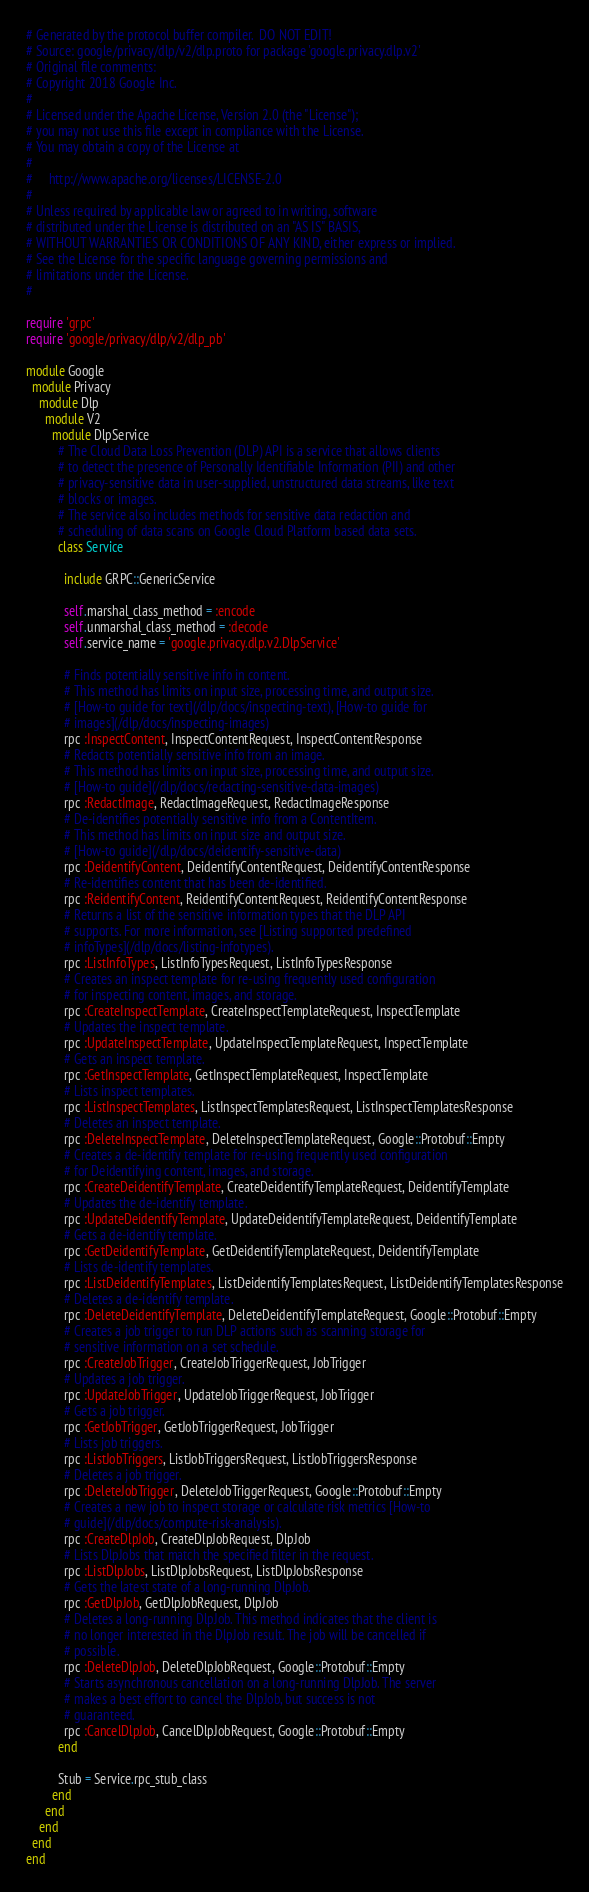<code> <loc_0><loc_0><loc_500><loc_500><_Ruby_># Generated by the protocol buffer compiler.  DO NOT EDIT!
# Source: google/privacy/dlp/v2/dlp.proto for package 'google.privacy.dlp.v2'
# Original file comments:
# Copyright 2018 Google Inc.
#
# Licensed under the Apache License, Version 2.0 (the "License");
# you may not use this file except in compliance with the License.
# You may obtain a copy of the License at
#
#     http://www.apache.org/licenses/LICENSE-2.0
#
# Unless required by applicable law or agreed to in writing, software
# distributed under the License is distributed on an "AS IS" BASIS,
# WITHOUT WARRANTIES OR CONDITIONS OF ANY KIND, either express or implied.
# See the License for the specific language governing permissions and
# limitations under the License.
#

require 'grpc'
require 'google/privacy/dlp/v2/dlp_pb'

module Google
  module Privacy
    module Dlp
      module V2
        module DlpService
          # The Cloud Data Loss Prevention (DLP) API is a service that allows clients
          # to detect the presence of Personally Identifiable Information (PII) and other
          # privacy-sensitive data in user-supplied, unstructured data streams, like text
          # blocks or images.
          # The service also includes methods for sensitive data redaction and
          # scheduling of data scans on Google Cloud Platform based data sets.
          class Service

            include GRPC::GenericService

            self.marshal_class_method = :encode
            self.unmarshal_class_method = :decode
            self.service_name = 'google.privacy.dlp.v2.DlpService'

            # Finds potentially sensitive info in content.
            # This method has limits on input size, processing time, and output size.
            # [How-to guide for text](/dlp/docs/inspecting-text), [How-to guide for
            # images](/dlp/docs/inspecting-images)
            rpc :InspectContent, InspectContentRequest, InspectContentResponse
            # Redacts potentially sensitive info from an image.
            # This method has limits on input size, processing time, and output size.
            # [How-to guide](/dlp/docs/redacting-sensitive-data-images)
            rpc :RedactImage, RedactImageRequest, RedactImageResponse
            # De-identifies potentially sensitive info from a ContentItem.
            # This method has limits on input size and output size.
            # [How-to guide](/dlp/docs/deidentify-sensitive-data)
            rpc :DeidentifyContent, DeidentifyContentRequest, DeidentifyContentResponse
            # Re-identifies content that has been de-identified.
            rpc :ReidentifyContent, ReidentifyContentRequest, ReidentifyContentResponse
            # Returns a list of the sensitive information types that the DLP API
            # supports. For more information, see [Listing supported predefined
            # infoTypes](/dlp/docs/listing-infotypes).
            rpc :ListInfoTypes, ListInfoTypesRequest, ListInfoTypesResponse
            # Creates an inspect template for re-using frequently used configuration
            # for inspecting content, images, and storage.
            rpc :CreateInspectTemplate, CreateInspectTemplateRequest, InspectTemplate
            # Updates the inspect template.
            rpc :UpdateInspectTemplate, UpdateInspectTemplateRequest, InspectTemplate
            # Gets an inspect template.
            rpc :GetInspectTemplate, GetInspectTemplateRequest, InspectTemplate
            # Lists inspect templates.
            rpc :ListInspectTemplates, ListInspectTemplatesRequest, ListInspectTemplatesResponse
            # Deletes an inspect template.
            rpc :DeleteInspectTemplate, DeleteInspectTemplateRequest, Google::Protobuf::Empty
            # Creates a de-identify template for re-using frequently used configuration
            # for Deidentifying content, images, and storage.
            rpc :CreateDeidentifyTemplate, CreateDeidentifyTemplateRequest, DeidentifyTemplate
            # Updates the de-identify template.
            rpc :UpdateDeidentifyTemplate, UpdateDeidentifyTemplateRequest, DeidentifyTemplate
            # Gets a de-identify template.
            rpc :GetDeidentifyTemplate, GetDeidentifyTemplateRequest, DeidentifyTemplate
            # Lists de-identify templates.
            rpc :ListDeidentifyTemplates, ListDeidentifyTemplatesRequest, ListDeidentifyTemplatesResponse
            # Deletes a de-identify template.
            rpc :DeleteDeidentifyTemplate, DeleteDeidentifyTemplateRequest, Google::Protobuf::Empty
            # Creates a job trigger to run DLP actions such as scanning storage for
            # sensitive information on a set schedule.
            rpc :CreateJobTrigger, CreateJobTriggerRequest, JobTrigger
            # Updates a job trigger.
            rpc :UpdateJobTrigger, UpdateJobTriggerRequest, JobTrigger
            # Gets a job trigger.
            rpc :GetJobTrigger, GetJobTriggerRequest, JobTrigger
            # Lists job triggers.
            rpc :ListJobTriggers, ListJobTriggersRequest, ListJobTriggersResponse
            # Deletes a job trigger.
            rpc :DeleteJobTrigger, DeleteJobTriggerRequest, Google::Protobuf::Empty
            # Creates a new job to inspect storage or calculate risk metrics [How-to
            # guide](/dlp/docs/compute-risk-analysis).
            rpc :CreateDlpJob, CreateDlpJobRequest, DlpJob
            # Lists DlpJobs that match the specified filter in the request.
            rpc :ListDlpJobs, ListDlpJobsRequest, ListDlpJobsResponse
            # Gets the latest state of a long-running DlpJob.
            rpc :GetDlpJob, GetDlpJobRequest, DlpJob
            # Deletes a long-running DlpJob. This method indicates that the client is
            # no longer interested in the DlpJob result. The job will be cancelled if
            # possible.
            rpc :DeleteDlpJob, DeleteDlpJobRequest, Google::Protobuf::Empty
            # Starts asynchronous cancellation on a long-running DlpJob. The server
            # makes a best effort to cancel the DlpJob, but success is not
            # guaranteed.
            rpc :CancelDlpJob, CancelDlpJobRequest, Google::Protobuf::Empty
          end

          Stub = Service.rpc_stub_class
        end
      end
    end
  end
end
</code> 